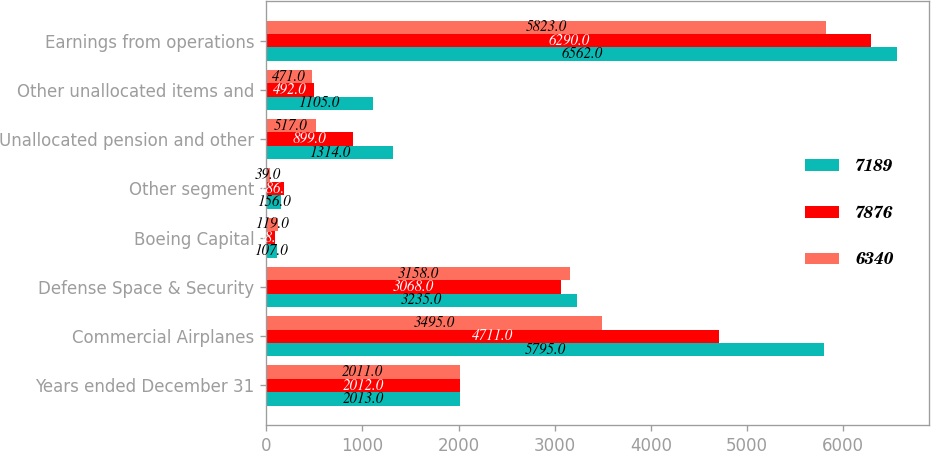Convert chart. <chart><loc_0><loc_0><loc_500><loc_500><stacked_bar_chart><ecel><fcel>Years ended December 31<fcel>Commercial Airplanes<fcel>Defense Space & Security<fcel>Boeing Capital<fcel>Other segment<fcel>Unallocated pension and other<fcel>Other unallocated items and<fcel>Earnings from operations<nl><fcel>7189<fcel>2013<fcel>5795<fcel>3235<fcel>107<fcel>156<fcel>1314<fcel>1105<fcel>6562<nl><fcel>7876<fcel>2012<fcel>4711<fcel>3068<fcel>88<fcel>186<fcel>899<fcel>492<fcel>6290<nl><fcel>6340<fcel>2011<fcel>3495<fcel>3158<fcel>119<fcel>39<fcel>517<fcel>471<fcel>5823<nl></chart> 